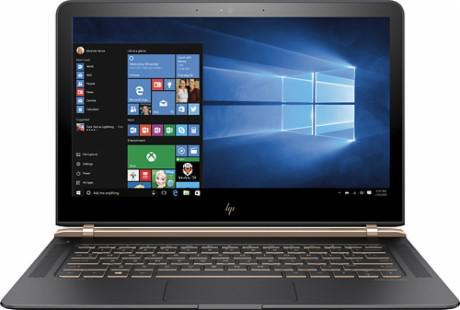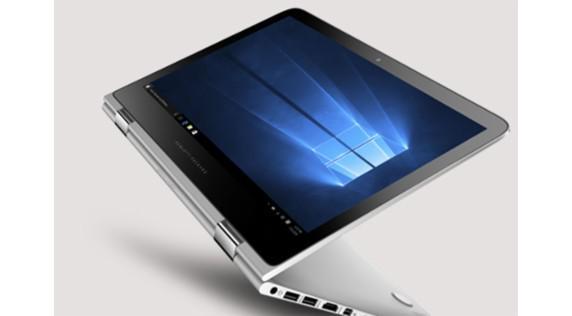The first image is the image on the left, the second image is the image on the right. Assess this claim about the two images: "the laptop on the right image has a black background". Correct or not? Answer yes or no. No. 